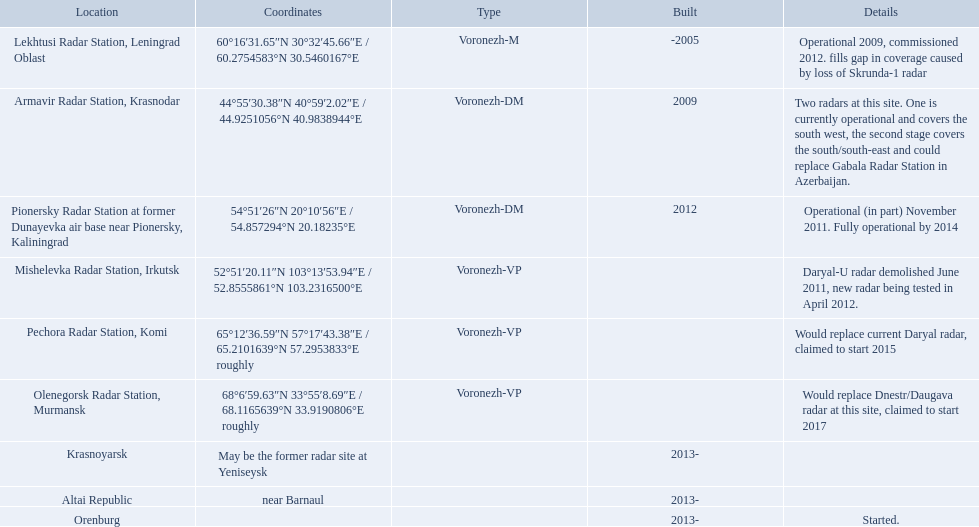What are the list of radar locations? Lekhtusi Radar Station, Leningrad Oblast, Armavir Radar Station, Krasnodar, Pionersky Radar Station at former Dunayevka air base near Pionersky, Kaliningrad, Mishelevka Radar Station, Irkutsk, Pechora Radar Station, Komi, Olenegorsk Radar Station, Murmansk, Krasnoyarsk, Altai Republic, Orenburg. Which of these are claimed to start in 2015? Pechora Radar Station, Komi. Which column has the coordinates starting with 60 deg? 60°16′31.65″N 30°32′45.66″E﻿ / ﻿60.2754583°N 30.5460167°E. What is the location in the same row as that column? Lekhtusi Radar Station, Leningrad Oblast. Voronezh radar has locations where? Lekhtusi Radar Station, Leningrad Oblast, Armavir Radar Station, Krasnodar, Pionersky Radar Station at former Dunayevka air base near Pionersky, Kaliningrad, Mishelevka Radar Station, Irkutsk, Pechora Radar Station, Komi, Olenegorsk Radar Station, Murmansk, Krasnoyarsk, Altai Republic, Orenburg. Which of these locations have know coordinates? Lekhtusi Radar Station, Leningrad Oblast, Armavir Radar Station, Krasnodar, Pionersky Radar Station at former Dunayevka air base near Pionersky, Kaliningrad, Mishelevka Radar Station, Irkutsk, Pechora Radar Station, Komi, Olenegorsk Radar Station, Murmansk. Which of these locations has coordinates of 60deg16'31.65''n 30deg32'45.66''e / 60.2754583degn 30.5460167dege? Lekhtusi Radar Station, Leningrad Oblast. Where are the positions of voronezh radar? Lekhtusi Radar Station, Leningrad Oblast, Armavir Radar Station, Krasnodar, Pionersky Radar Station at former Dunayevka air base near Pionersky, Kaliningrad, Mishelevka Radar Station, Irkutsk, Pechora Radar Station, Komi, Olenegorsk Radar Station, Murmansk, Krasnoyarsk, Altai Republic, Orenburg. Which of these positions have identified coordinates? Lekhtusi Radar Station, Leningrad Oblast, Armavir Radar Station, Krasnodar, Pionersky Radar Station at former Dunayevka air base near Pionersky, Kaliningrad, Mishelevka Radar Station, Irkutsk, Pechora Radar Station, Komi, Olenegorsk Radar Station, Murmansk. Which of these positions has coordinates of 60deg16'31.65''n 30deg32'45.66''e / 60.2754583degn 30.5460167dege? Lekhtusi Radar Station, Leningrad Oblast. What are the complete list of sites? Lekhtusi Radar Station, Leningrad Oblast, Armavir Radar Station, Krasnodar, Pionersky Radar Station at former Dunayevka air base near Pionersky, Kaliningrad, Mishelevka Radar Station, Irkutsk, Pechora Radar Station, Komi, Olenegorsk Radar Station, Murmansk, Krasnoyarsk, Altai Republic, Orenburg. And which site has coordinates 60deg16'31.65''n 30deg32'45.66''e / 60.2754583degn 30.5460167dege? Lekhtusi Radar Station, Leningrad Oblast. Which voronezh radar has commenced operation? Orenburg. Which radar is intended to replace dnestr/daugava? Olenegorsk Radar Station, Murmansk. Which radar began functioning in 2015? Pechora Radar Station, Komi. What is the location of each radar? Lekhtusi Radar Station, Leningrad Oblast, Armavir Radar Station, Krasnodar, Pionersky Radar Station at former Dunayevka air base near Pionersky, Kaliningrad, Mishelevka Radar Station, Irkutsk, Pechora Radar Station, Komi, Olenegorsk Radar Station, Murmansk, Krasnoyarsk, Altai Republic, Orenburg. What are the particulars of each radar? Operational 2009, commissioned 2012. fills gap in coverage caused by loss of Skrunda-1 radar, Two radars at this site. One is currently operational and covers the south west, the second stage covers the south/south-east and could replace Gabala Radar Station in Azerbaijan., Operational (in part) November 2011. Fully operational by 2014, Daryal-U radar demolished June 2011, new radar being tested in April 2012., Would replace current Daryal radar, claimed to start 2015, Would replace Dnestr/Daugava radar at this site, claimed to start 2017, , , Started. Which radar is planned to begin in 2015? Pechora Radar Station, Komi. What are every one of the places? Lekhtusi Radar Station, Leningrad Oblast, Armavir Radar Station, Krasnodar, Pionersky Radar Station at former Dunayevka air base near Pionersky, Kaliningrad, Mishelevka Radar Station, Irkutsk, Pechora Radar Station, Komi, Olenegorsk Radar Station, Murmansk, Krasnoyarsk, Altai Republic, Orenburg. And which place's coordinates are 60deg16'31.65''n 30deg32'45.66''e / 60.2754583degn 30.5460167dege? Lekhtusi Radar Station, Leningrad Oblast. In which column do the coordinates start at 60 degrees? 60°16′31.65″N 30°32′45.66″E﻿ / ﻿60.2754583°N 30.5460167°E. What is the place in the corresponding row of that column? Lekhtusi Radar Station, Leningrad Oblast. Parse the full table. {'header': ['Location', 'Coordinates', 'Type', 'Built', 'Details'], 'rows': [['Lekhtusi Radar Station, Leningrad Oblast', '60°16′31.65″N 30°32′45.66″E\ufeff / \ufeff60.2754583°N 30.5460167°E', 'Voronezh-M', '-2005', 'Operational 2009, commissioned 2012. fills gap in coverage caused by loss of Skrunda-1 radar'], ['Armavir Radar Station, Krasnodar', '44°55′30.38″N 40°59′2.02″E\ufeff / \ufeff44.9251056°N 40.9838944°E', 'Voronezh-DM', '2009', 'Two radars at this site. One is currently operational and covers the south west, the second stage covers the south/south-east and could replace Gabala Radar Station in Azerbaijan.'], ['Pionersky Radar Station at former Dunayevka air base near Pionersky, Kaliningrad', '54°51′26″N 20°10′56″E\ufeff / \ufeff54.857294°N 20.18235°E', 'Voronezh-DM', '2012', 'Operational (in part) November 2011. Fully operational by 2014'], ['Mishelevka Radar Station, Irkutsk', '52°51′20.11″N 103°13′53.94″E\ufeff / \ufeff52.8555861°N 103.2316500°E', 'Voronezh-VP', '', 'Daryal-U radar demolished June 2011, new radar being tested in April 2012.'], ['Pechora Radar Station, Komi', '65°12′36.59″N 57°17′43.38″E\ufeff / \ufeff65.2101639°N 57.2953833°E roughly', 'Voronezh-VP', '', 'Would replace current Daryal radar, claimed to start 2015'], ['Olenegorsk Radar Station, Murmansk', '68°6′59.63″N 33°55′8.69″E\ufeff / \ufeff68.1165639°N 33.9190806°E roughly', 'Voronezh-VP', '', 'Would replace Dnestr/Daugava radar at this site, claimed to start 2017'], ['Krasnoyarsk', 'May be the former radar site at Yeniseysk', '', '2013-', ''], ['Altai Republic', 'near Barnaul', '', '2013-', ''], ['Orenburg', '', '', '2013-', 'Started.']]} Which column contains coordinates that start with 60 degrees? 60°16′31.65″N 30°32′45.66″E﻿ / ﻿60.2754583°N 30.5460167°E. What location can be found in the corresponding row of that column? Lekhtusi Radar Station, Leningrad Oblast. What are the different locations? Lekhtusi Radar Station, Leningrad Oblast, Armavir Radar Station, Krasnodar, Pionersky Radar Station at former Dunayevka air base near Pionersky, Kaliningrad, Mishelevka Radar Station, Irkutsk, Pechora Radar Station, Komi, Olenegorsk Radar Station, Murmansk, Krasnoyarsk, Altai Republic, Orenburg. And which specific location has the coordinates 60deg16'31.65''n 30deg32'45.66''e / 60.2754583degn 30.5460167dege? Lekhtusi Radar Station, Leningrad Oblast. In which locations can the voronezh radar be found? Lekhtusi Radar Station, Leningrad Oblast, Armavir Radar Station, Krasnodar, Pionersky Radar Station at former Dunayevka air base near Pionersky, Kaliningrad, Mishelevka Radar Station, Irkutsk, Pechora Radar Station, Komi, Olenegorsk Radar Station, Murmansk, Krasnoyarsk, Altai Republic, Orenburg. Which of these locations possess known coordinates? Lekhtusi Radar Station, Leningrad Oblast, Armavir Radar Station, Krasnodar, Pionersky Radar Station at former Dunayevka air base near Pionersky, Kaliningrad, Mishelevka Radar Station, Irkutsk, Pechora Radar Station, Komi, Olenegorsk Radar Station, Murmansk. Which location has the coordinates of 60°16'31.65"n 30°32'45.66"e / 60.2754583°n 30.5460167°e? Lekhtusi Radar Station, Leningrad Oblast. 